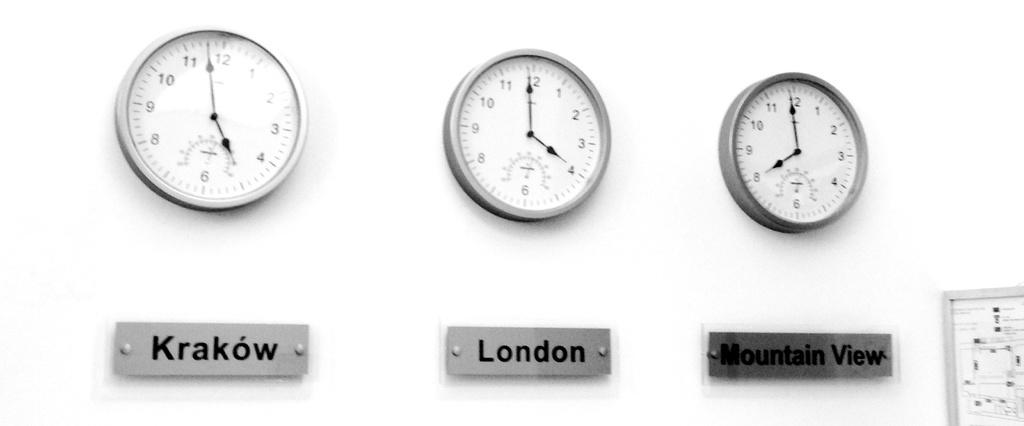Provide a one-sentence caption for the provided image. Three clocks with the times for Krakow, London and Mountain View. 